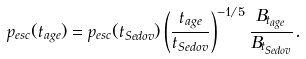<formula> <loc_0><loc_0><loc_500><loc_500>p _ { e s c } ( t _ { a g e } ) = p _ { e s c } ( t _ { S e d o v } ) \left ( \frac { t _ { a g e } } { t _ { S e d o v } } \right ) ^ { - 1 / 5 } \frac { B _ { t _ { a g e } } } { B _ { t _ { S e d o v } } } .</formula> 